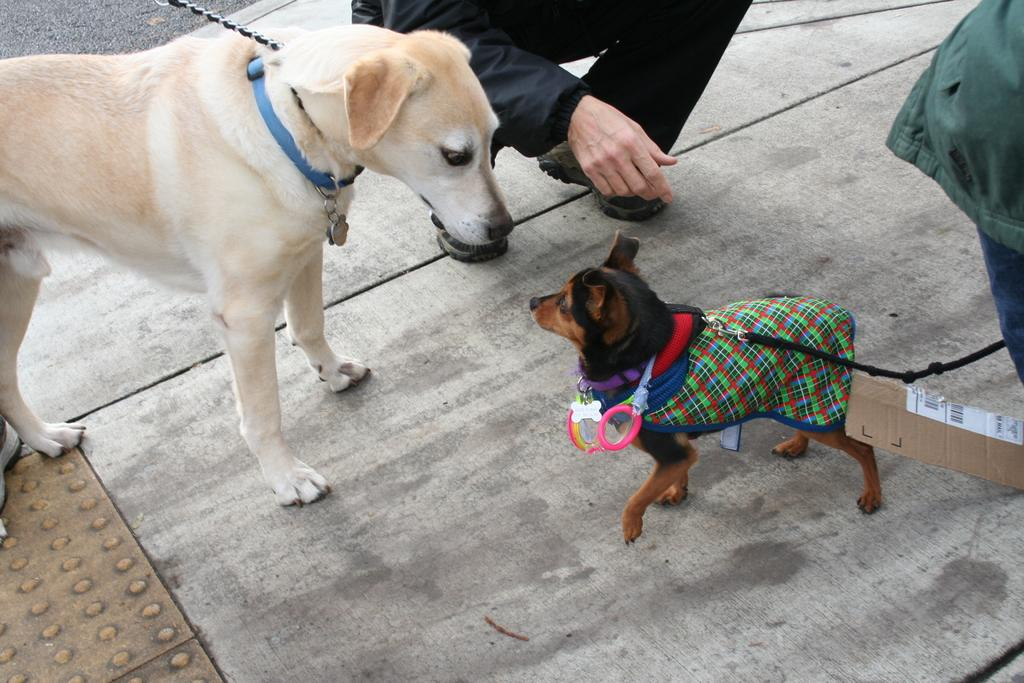What types of living organisms are in the front of the image? There are animals in the front of the image. Where is the person located in the image? The person is in the background of the image. What can be seen on the right side of the image? There is an object on the right side of the image. What colors are used to depict the object? The object is blue and green in color. How many snails can be seen crawling on the floor in the image? There are no snails present in the image, and the floor is not visible. 